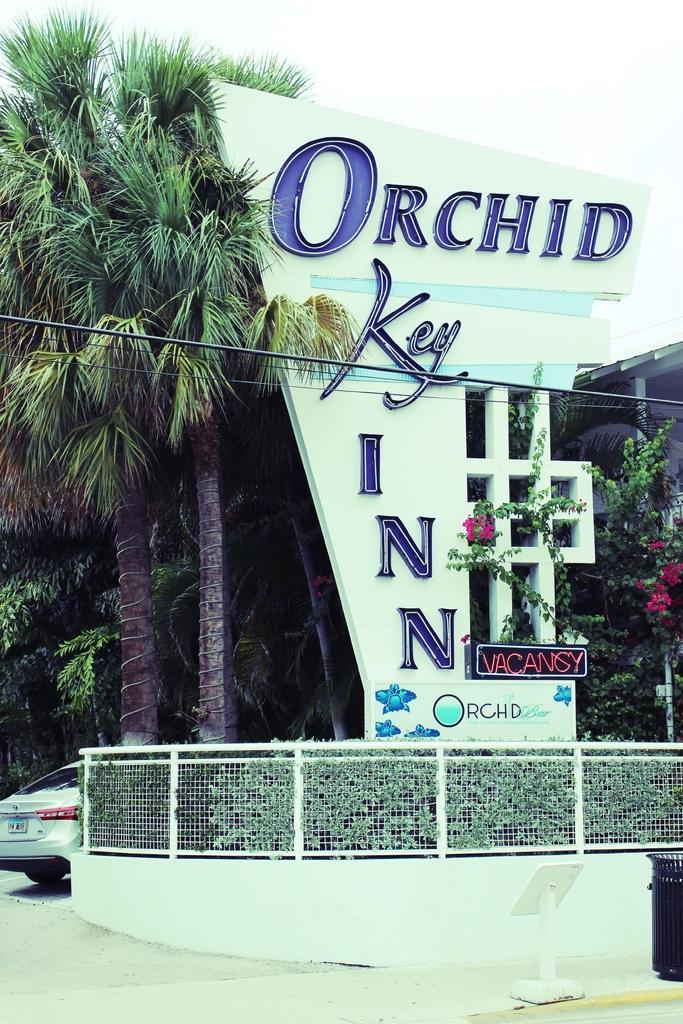Please provide a concise description of this image. In this picture I can see the car which is parked near to the fencing. On the right I can see the board. In the background I can see the building, trees and flowers. At the top I can see the sky. 